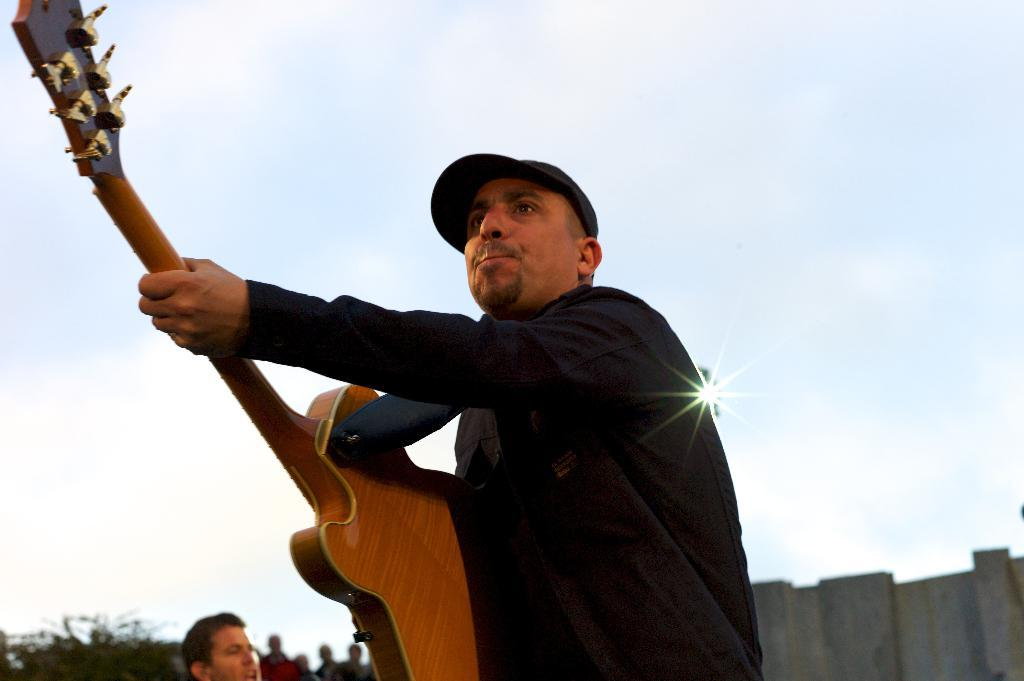What is the person in the image holding? The person is holding a guitar. Are there any other people in the image besides the person with the guitar? Yes, there is a group of people standing in the image. Can you describe the lighting in the image? There is a light in the image. What type of insurance policy is the person with the guitar discussing with the group? There is no indication in the image that the person with the guitar or the group is discussing insurance. 